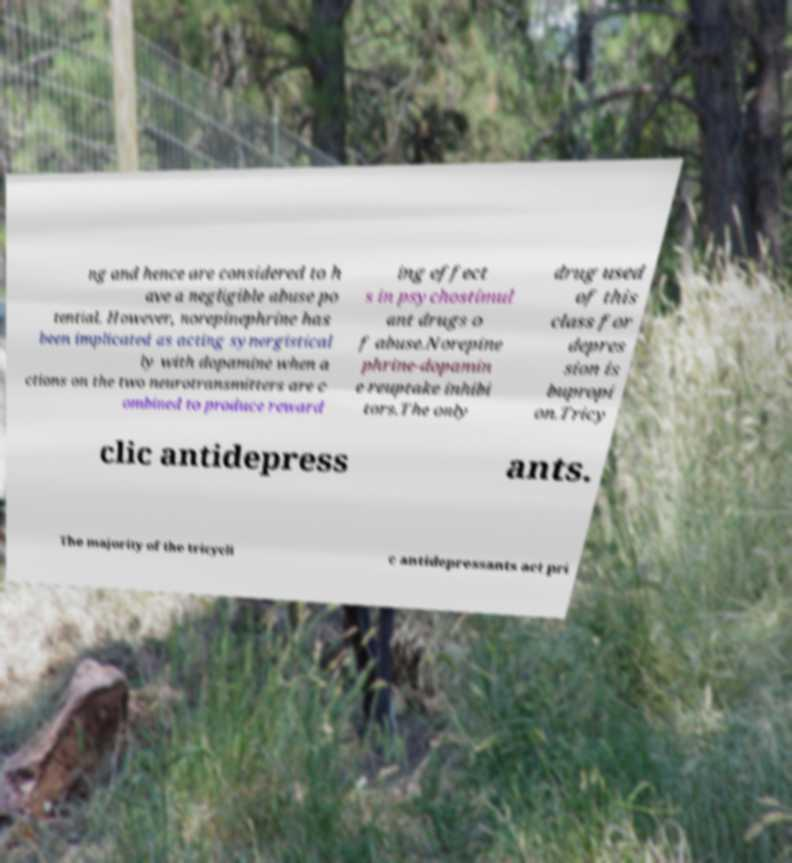Please read and relay the text visible in this image. What does it say? ng and hence are considered to h ave a negligible abuse po tential. However, norepinephrine has been implicated as acting synergistical ly with dopamine when a ctions on the two neurotransmitters are c ombined to produce reward ing effect s in psychostimul ant drugs o f abuse.Norepine phrine-dopamin e reuptake inhibi tors.The only drug used of this class for depres sion is bupropi on.Tricy clic antidepress ants. The majority of the tricycli c antidepressants act pri 